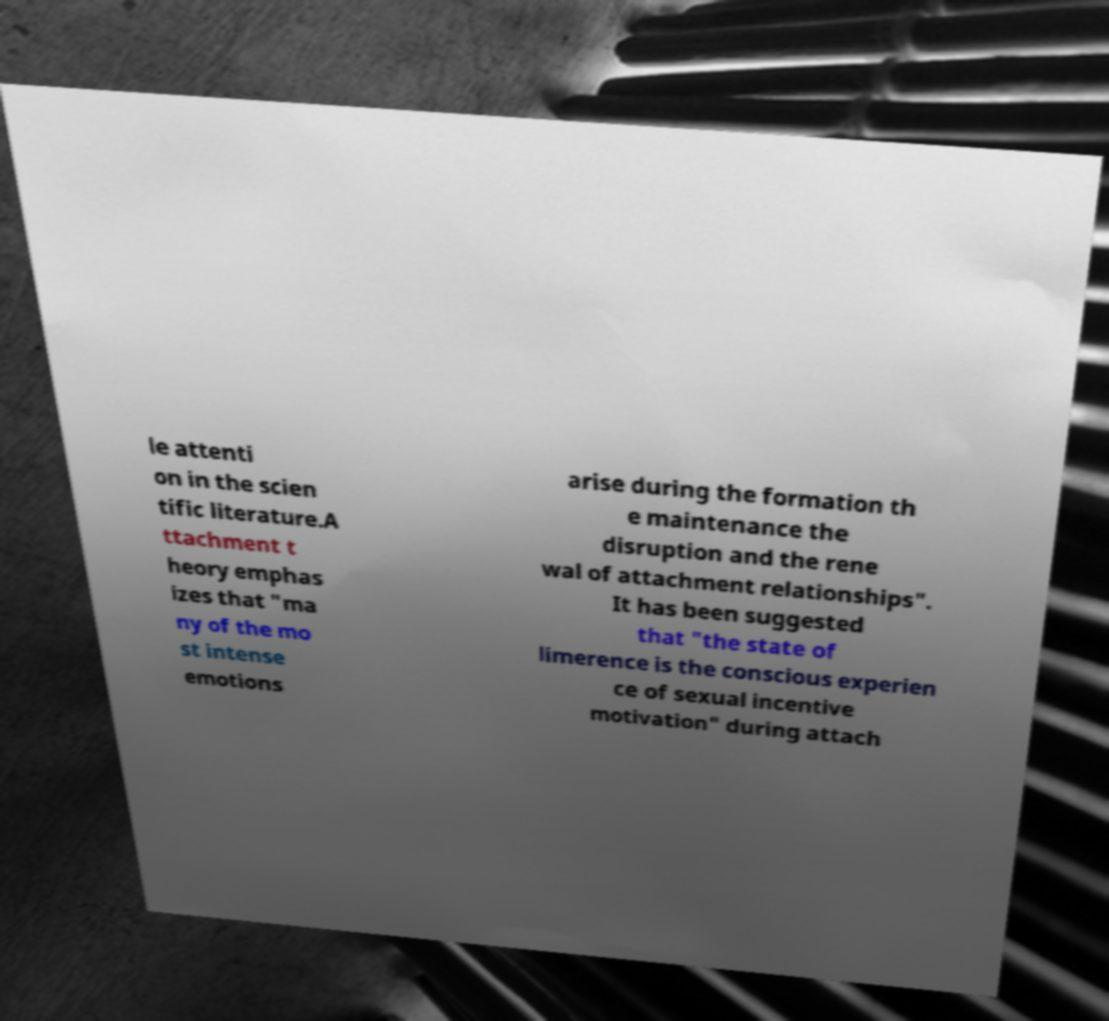Please identify and transcribe the text found in this image. le attenti on in the scien tific literature.A ttachment t heory emphas izes that "ma ny of the mo st intense emotions arise during the formation th e maintenance the disruption and the rene wal of attachment relationships". It has been suggested that "the state of limerence is the conscious experien ce of sexual incentive motivation" during attach 